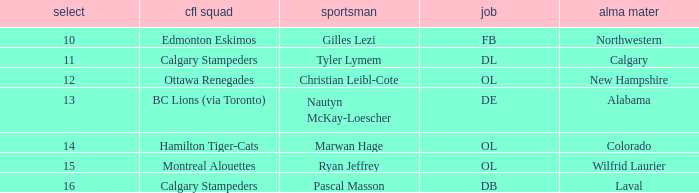Which player from the 2004 CFL draft attended Wilfrid Laurier? Ryan Jeffrey. 